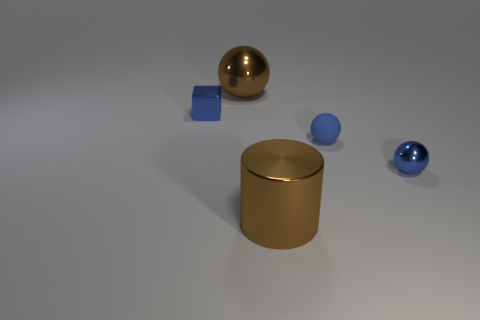Add 2 large green blocks. How many objects exist? 7 Subtract all cubes. How many objects are left? 4 Add 5 cyan objects. How many cyan objects exist? 5 Subtract 0 brown blocks. How many objects are left? 5 Subtract all tiny shiny things. Subtract all blue things. How many objects are left? 0 Add 1 small matte objects. How many small matte objects are left? 2 